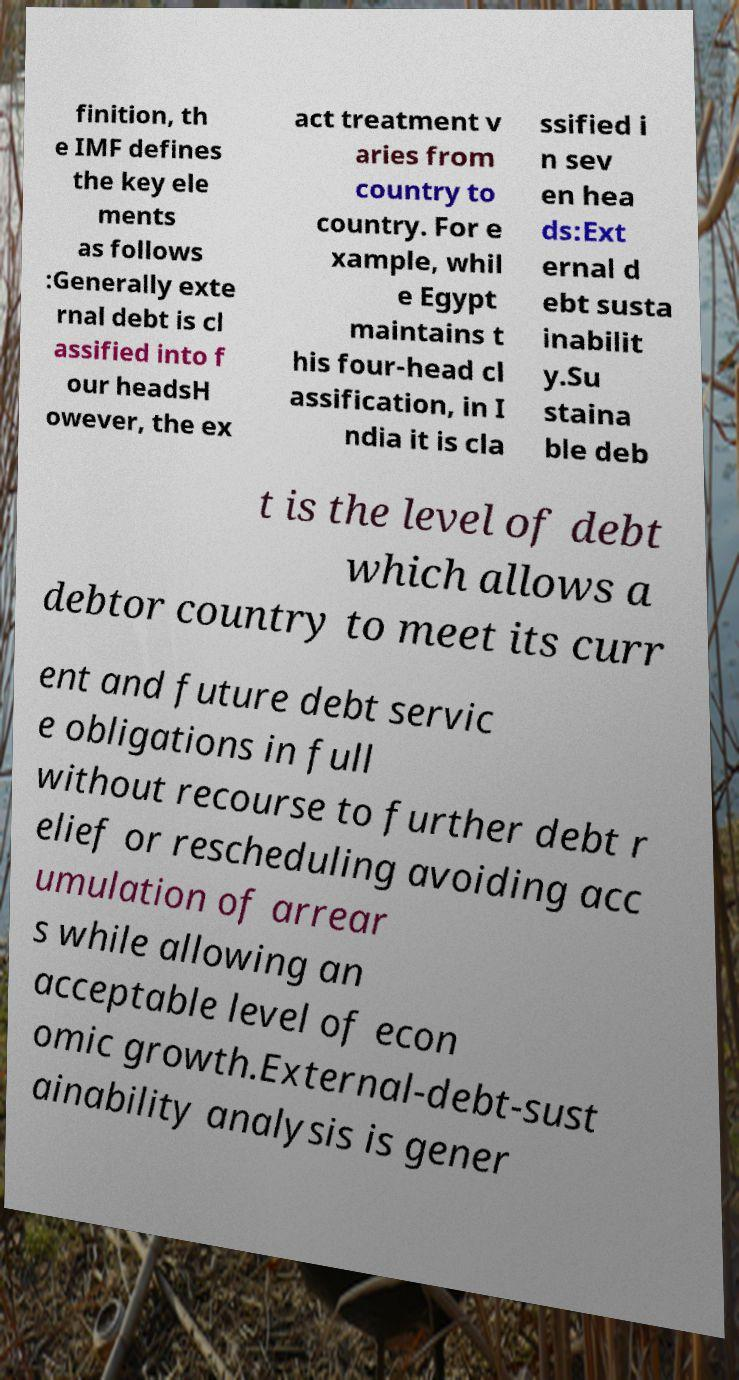Can you read and provide the text displayed in the image?This photo seems to have some interesting text. Can you extract and type it out for me? finition, th e IMF defines the key ele ments as follows :Generally exte rnal debt is cl assified into f our headsH owever, the ex act treatment v aries from country to country. For e xample, whil e Egypt maintains t his four-head cl assification, in I ndia it is cla ssified i n sev en hea ds:Ext ernal d ebt susta inabilit y.Su staina ble deb t is the level of debt which allows a debtor country to meet its curr ent and future debt servic e obligations in full without recourse to further debt r elief or rescheduling avoiding acc umulation of arrear s while allowing an acceptable level of econ omic growth.External-debt-sust ainability analysis is gener 